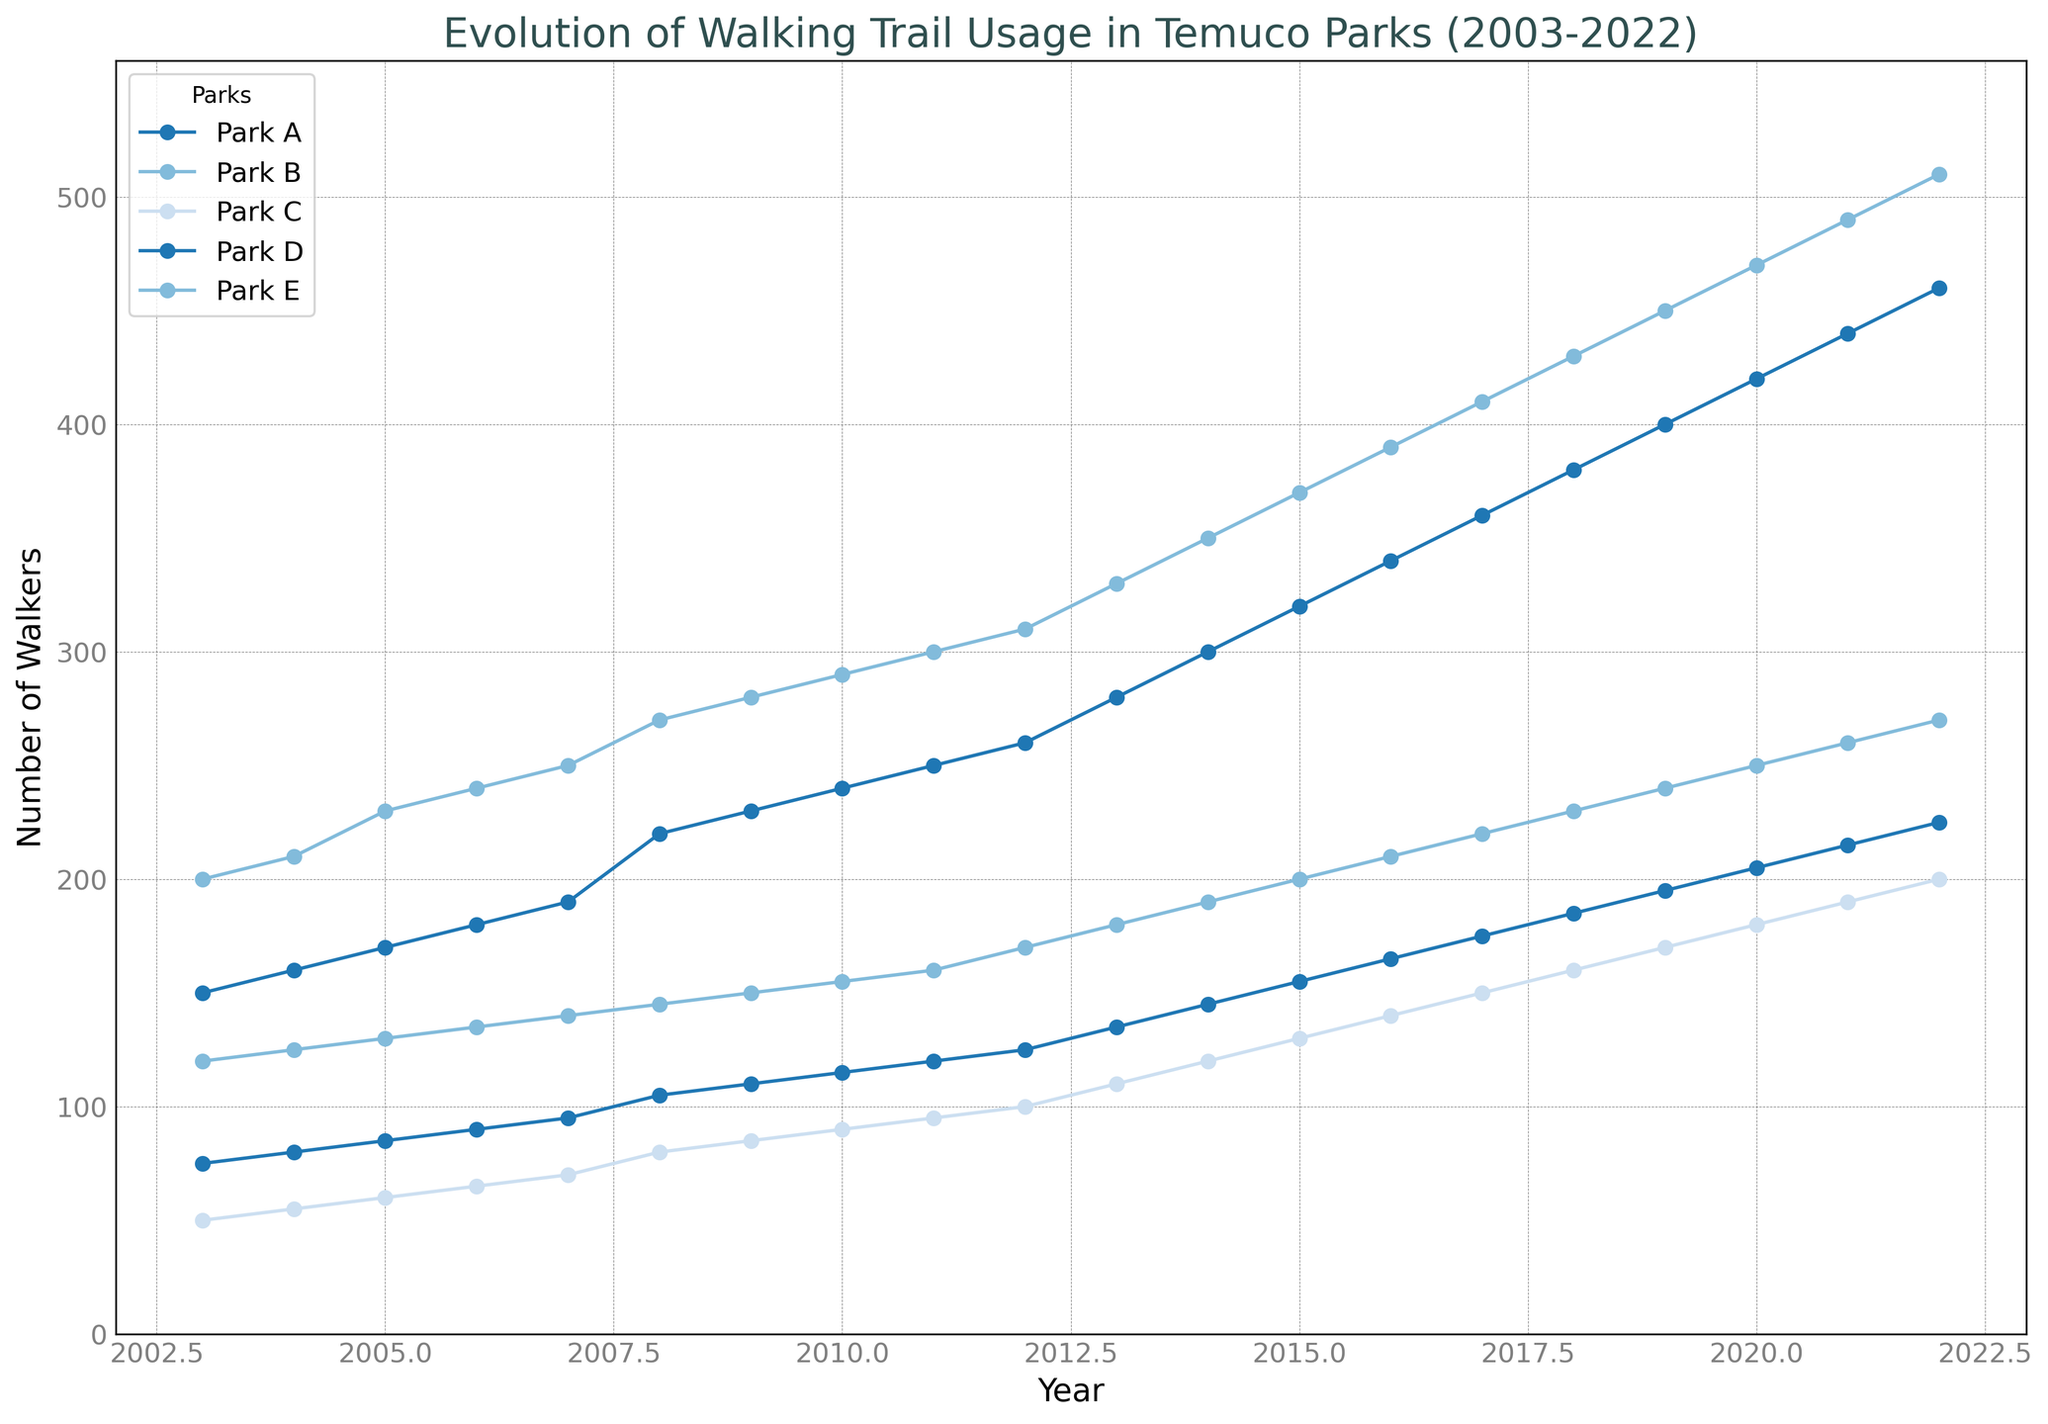Which park had the highest number of walkers in 2022? Looking at the year 2022 on the x-axis, find the data points of all parks. The highest point corresponds to Park B.
Answer: Park B Between which years did Park C see the most significant increase in walkers? Examine the slope of Park C's line. The steepest slope appears between 2011 and 2012.
Answer: 2011 - 2012 Which park consistently had the lowest number of walkers over the 20 years? Compare the lines and note the lowest one throughout the period. Park C consistently has the lowest number of walkers.
Answer: Park C In which year did Park A have 300 walkers? Trace Park A's line and find where it intersects with 300 on the y-axis. This happens in 2014.
Answer: 2014 What is the difference in the number of walkers in Park E between 2005 and 2020? Find the number of walkers for Park E in these years: 130 in 2005 and 250 in 2020. The difference is 250 - 130 = 120.
Answer: 120 Which park has shown the most overall increase from 2003 to 2022? Calculate the difference between 2003 and 2022 for each park and compare. Park E increases from 120 to 270, the highest increase of 150.
Answer: Park E What is the total number of walkers in all parks combined for the year 2006? Add the number of walkers for each park in 2006: 180 + 240 + 65 + 90 + 135 = 710.
Answer: 710 Which park’s number of walkers first reached 400? Examine the lines and notice when each reaches 400. Park A reaches 400 first in 2019.
Answer: Park A On average, how many walkers did Park B get annually over the 20 years? Sum the annual values for Park B and divide by 20: (200 + 210 + 230 + 240 + 250 + 270 + 280 + 290 + 300 + 310 + 330 + 350 + 370 + 390 + 410 + 430 + 450 + 470 + 490 + 510) / 20 = 3270 / 20 = 163.5
Answer: 163.5 